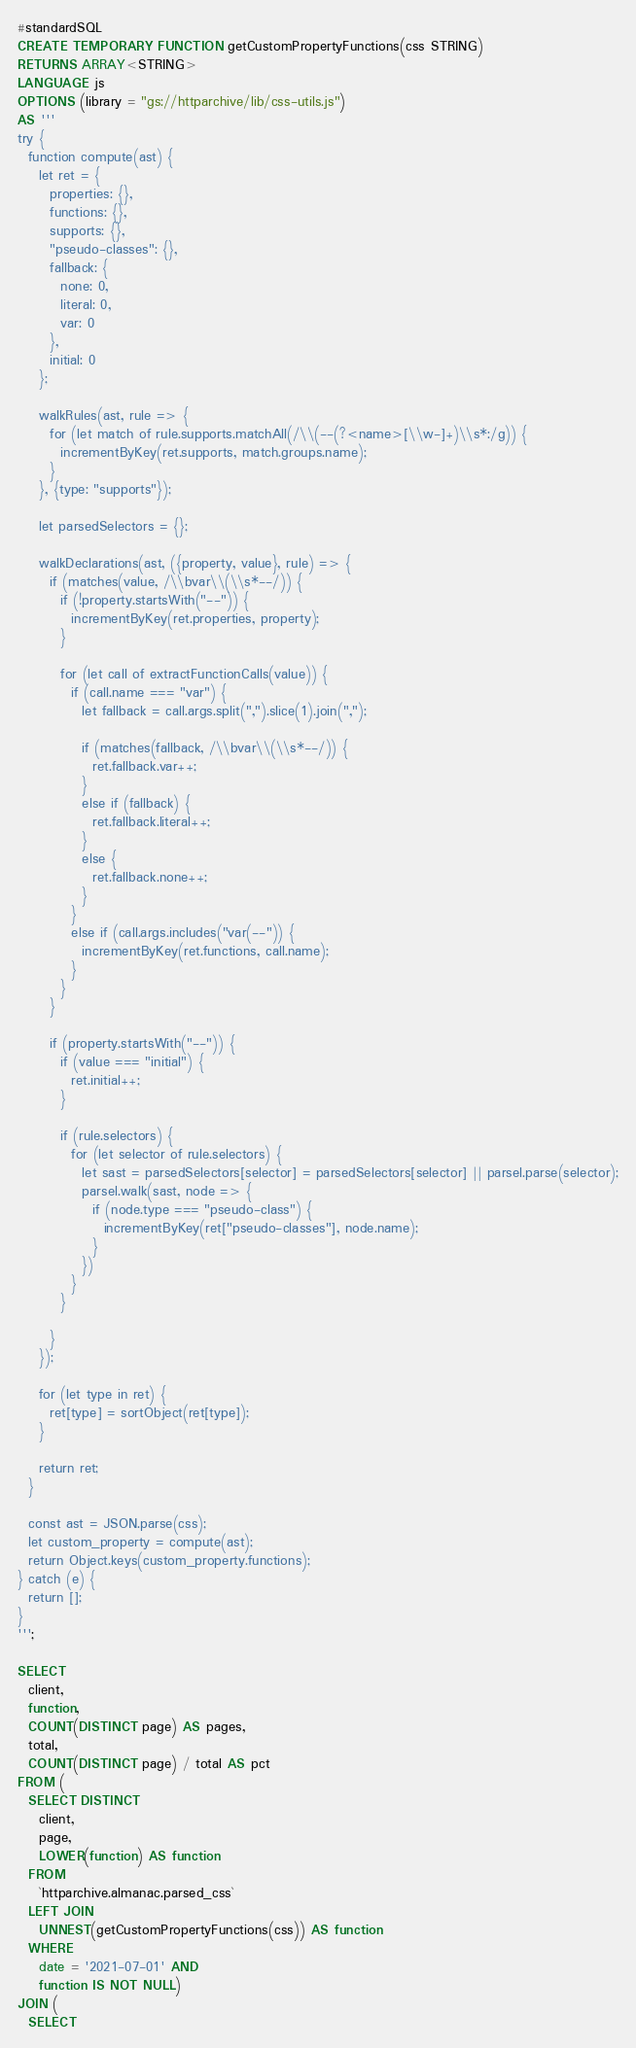<code> <loc_0><loc_0><loc_500><loc_500><_SQL_>#standardSQL
CREATE TEMPORARY FUNCTION getCustomPropertyFunctions(css STRING)
RETURNS ARRAY<STRING>
LANGUAGE js
OPTIONS (library = "gs://httparchive/lib/css-utils.js")
AS '''
try {
  function compute(ast) {
    let ret = {
      properties: {},
      functions: {},
      supports: {},
      "pseudo-classes": {},
      fallback: {
        none: 0,
        literal: 0,
        var: 0
      },
      initial: 0
    };

    walkRules(ast, rule => {
      for (let match of rule.supports.matchAll(/\\(--(?<name>[\\w-]+)\\s*:/g)) {
        incrementByKey(ret.supports, match.groups.name);
      }
    }, {type: "supports"});

    let parsedSelectors = {};

    walkDeclarations(ast, ({property, value}, rule) => {
      if (matches(value, /\\bvar\\(\\s*--/)) {
        if (!property.startsWith("--")) {
          incrementByKey(ret.properties, property);
        }

        for (let call of extractFunctionCalls(value)) {
          if (call.name === "var") {
            let fallback = call.args.split(",").slice(1).join(",");

            if (matches(fallback, /\\bvar\\(\\s*--/)) {
              ret.fallback.var++;
            }
            else if (fallback) {
              ret.fallback.literal++;
            }
            else {
              ret.fallback.none++;
            }
          }
          else if (call.args.includes("var(--")) {
            incrementByKey(ret.functions, call.name);
          }
        }
      }

      if (property.startsWith("--")) {
        if (value === "initial") {
          ret.initial++;
        }

        if (rule.selectors) {
          for (let selector of rule.selectors) {
            let sast = parsedSelectors[selector] = parsedSelectors[selector] || parsel.parse(selector);
            parsel.walk(sast, node => {
              if (node.type === "pseudo-class") {
                incrementByKey(ret["pseudo-classes"], node.name);
              }
            })
          }
        }

      }
    });

    for (let type in ret) {
      ret[type] = sortObject(ret[type]);
    }

    return ret;
  }

  const ast = JSON.parse(css);
  let custom_property = compute(ast);
  return Object.keys(custom_property.functions);
} catch (e) {
  return [];
}
''';

SELECT
  client,
  function,
  COUNT(DISTINCT page) AS pages,
  total,
  COUNT(DISTINCT page) / total AS pct
FROM (
  SELECT DISTINCT
    client,
    page,
    LOWER(function) AS function
  FROM
    `httparchive.almanac.parsed_css`
  LEFT JOIN
    UNNEST(getCustomPropertyFunctions(css)) AS function
  WHERE
    date = '2021-07-01' AND
    function IS NOT NULL)
JOIN (
  SELECT</code> 